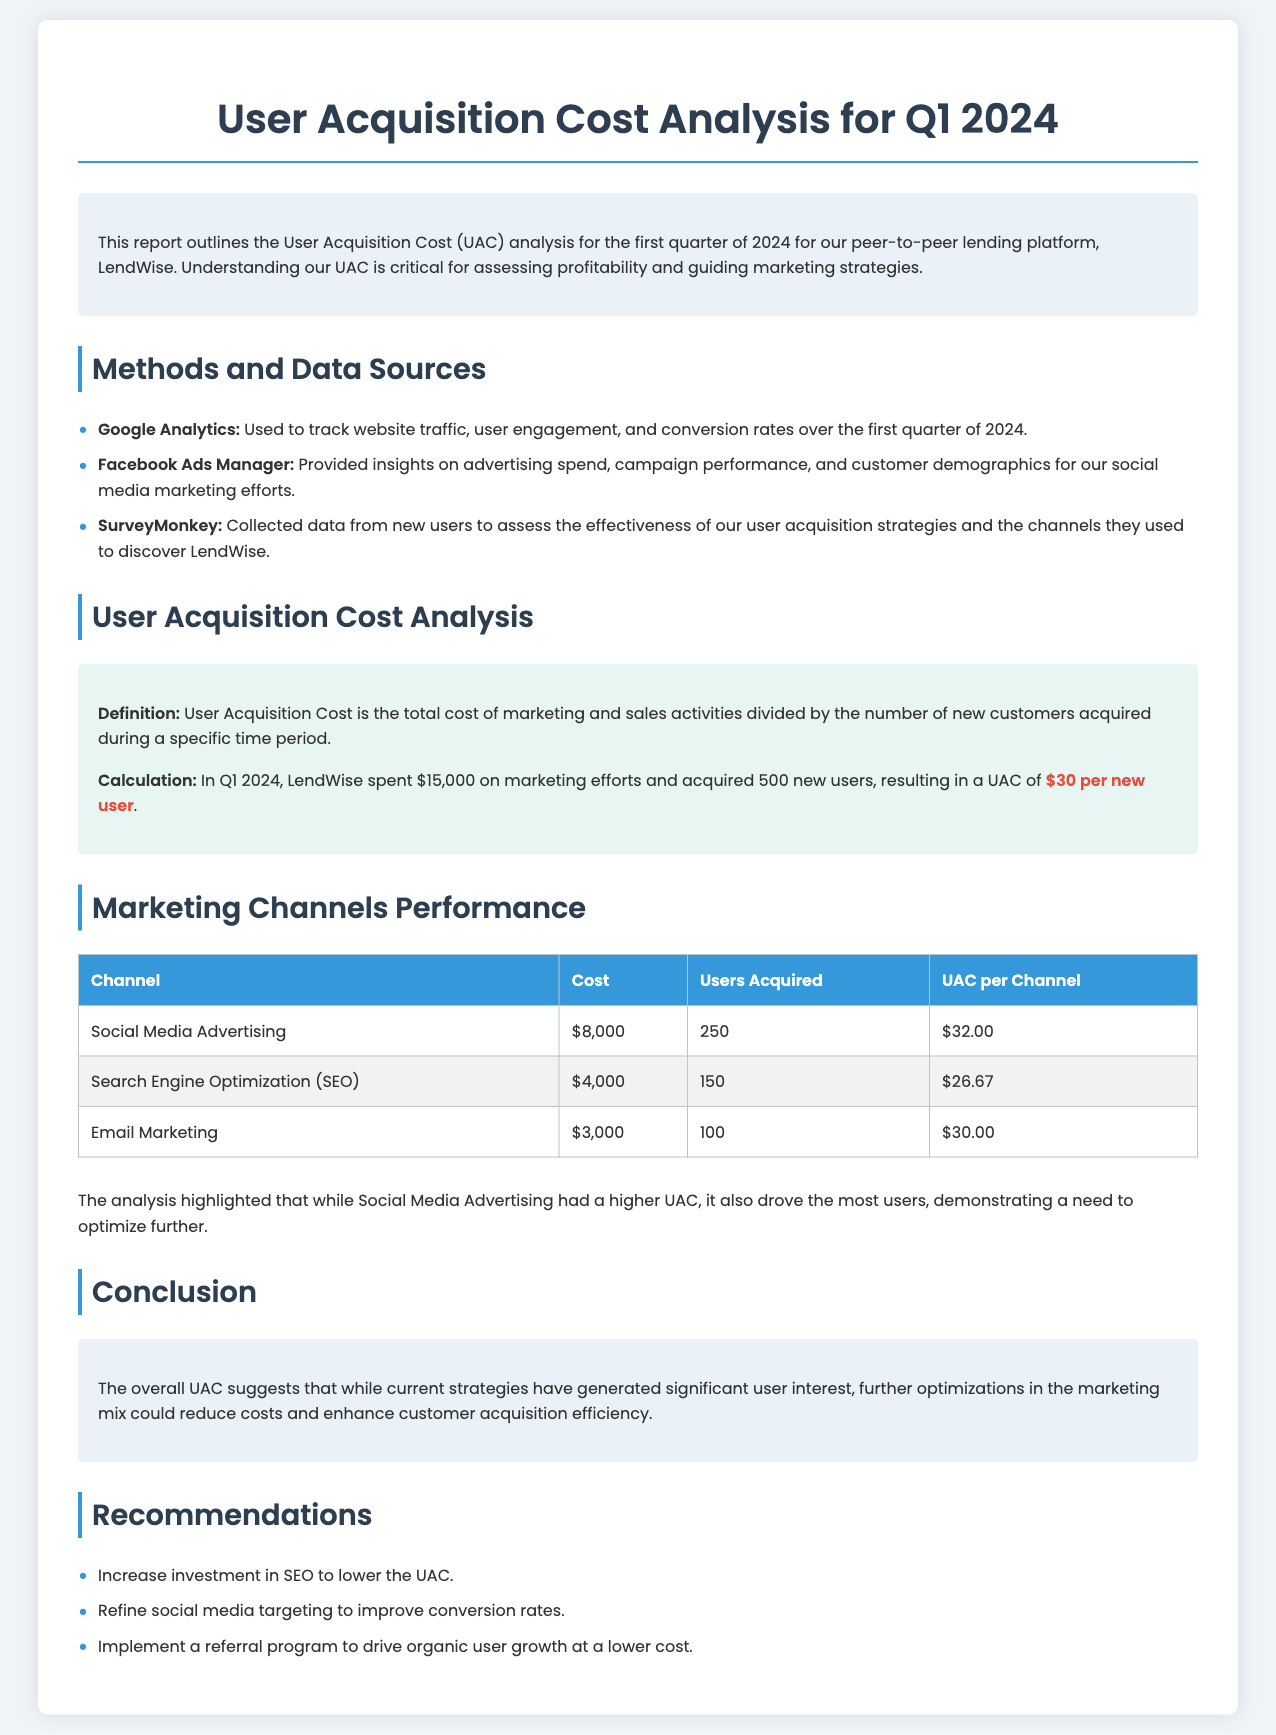What is the total marketing spend in Q1 2024? The total marketing spend is listed in the document as $15,000.
Answer: $15,000 How many new users were acquired in Q1 2024? The document states that LendWise acquired 500 new users.
Answer: 500 What is the UAC for LendWise in Q1 2024? The UAC is calculated based on marketing costs and new users, yielding $30 per new user.
Answer: $30 per new user Which marketing channel had the highest acquisition cost? The document indicates that Social Media Advertising had the highest UAC at $32.00.
Answer: $32.00 What was the cost for Search Engine Optimization? The cost for SEO is detailed as $4,000 in the document.
Answer: $4,000 Which marketing strategy is recommended for reducing UAC? The report recommends increasing investment in SEO to reduce UAC.
Answer: Increase investment in SEO What source was used to track website traffic? The document mentions Google Analytics as the source for tracking website traffic.
Answer: Google Analytics What was the primary goal of the document? The primary goal was to analyze User Acquisition Cost to assess profitability for LendWise.
Answer: Analyze User Acquisition Cost How many users did Email Marketing acquire? The analysis shows that Email Marketing acquired 100 new users.
Answer: 100 